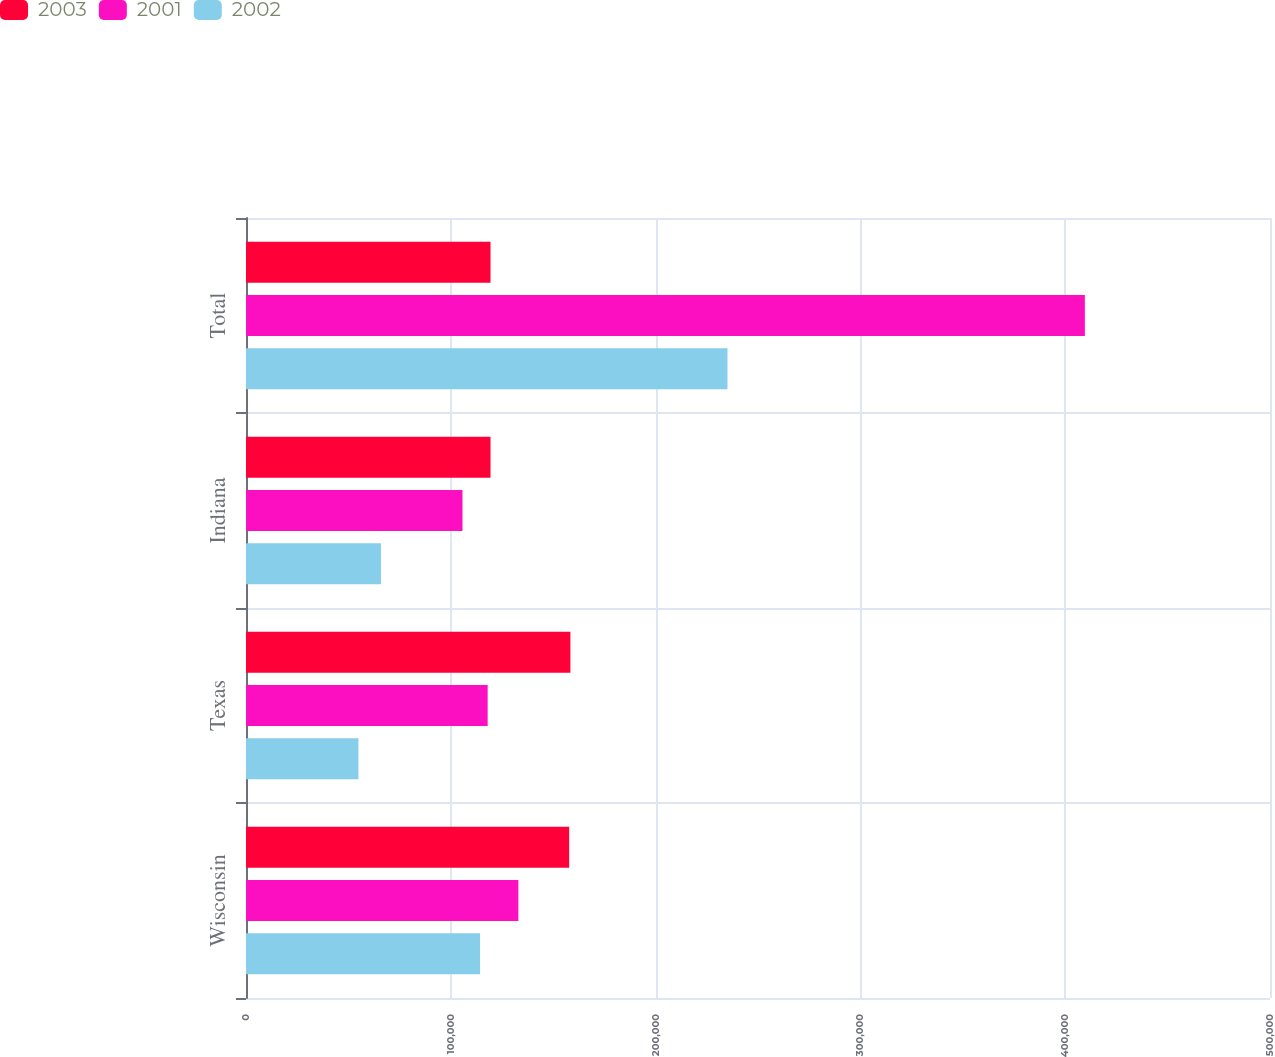Convert chart. <chart><loc_0><loc_0><loc_500><loc_500><stacked_bar_chart><ecel><fcel>Wisconsin<fcel>Texas<fcel>Indiana<fcel>Total<nl><fcel>2003<fcel>157800<fcel>158400<fcel>119400<fcel>119400<nl><fcel>2001<fcel>133000<fcel>118000<fcel>105700<fcel>409600<nl><fcel>2002<fcel>114300<fcel>54900<fcel>65900<fcel>235100<nl></chart> 